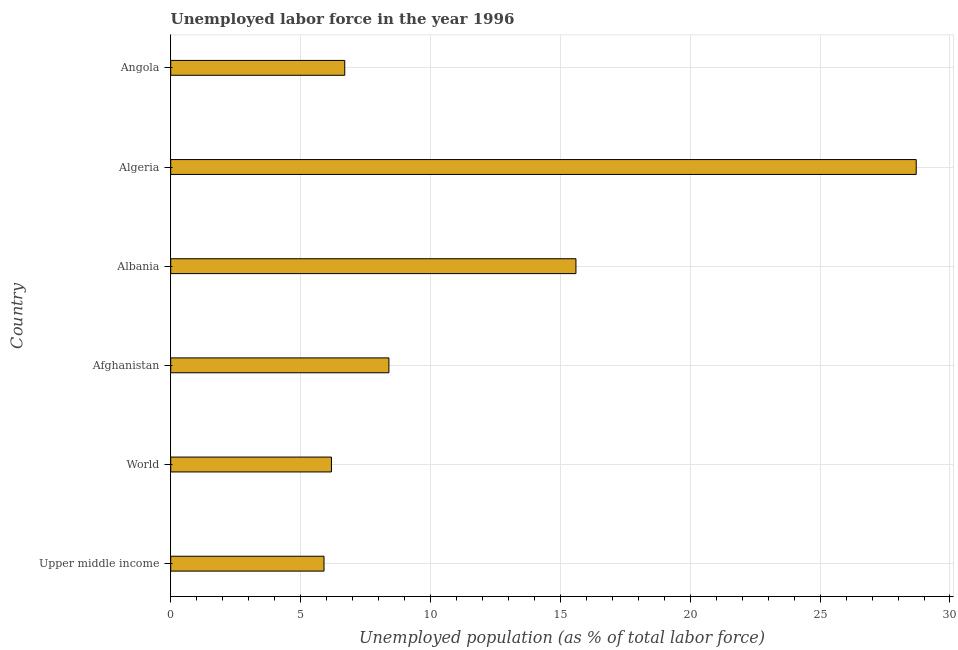Does the graph contain any zero values?
Ensure brevity in your answer.  No. Does the graph contain grids?
Give a very brief answer. Yes. What is the title of the graph?
Your answer should be very brief. Unemployed labor force in the year 1996. What is the label or title of the X-axis?
Provide a short and direct response. Unemployed population (as % of total labor force). What is the label or title of the Y-axis?
Offer a very short reply. Country. What is the total unemployed population in Algeria?
Provide a succinct answer. 28.7. Across all countries, what is the maximum total unemployed population?
Provide a succinct answer. 28.7. Across all countries, what is the minimum total unemployed population?
Your response must be concise. 5.9. In which country was the total unemployed population maximum?
Your answer should be compact. Algeria. In which country was the total unemployed population minimum?
Provide a succinct answer. Upper middle income. What is the sum of the total unemployed population?
Offer a terse response. 71.49. What is the difference between the total unemployed population in Afghanistan and Upper middle income?
Offer a very short reply. 2.5. What is the average total unemployed population per country?
Give a very brief answer. 11.91. What is the median total unemployed population?
Offer a very short reply. 7.55. What is the ratio of the total unemployed population in Albania to that in World?
Your response must be concise. 2.52. Is the difference between the total unemployed population in Albania and Angola greater than the difference between any two countries?
Your answer should be compact. No. What is the difference between the highest and the second highest total unemployed population?
Offer a terse response. 13.1. Is the sum of the total unemployed population in Albania and Upper middle income greater than the maximum total unemployed population across all countries?
Ensure brevity in your answer.  No. What is the difference between the highest and the lowest total unemployed population?
Offer a terse response. 22.8. How many bars are there?
Keep it short and to the point. 6. Are all the bars in the graph horizontal?
Provide a short and direct response. Yes. How many countries are there in the graph?
Make the answer very short. 6. What is the difference between two consecutive major ticks on the X-axis?
Give a very brief answer. 5. What is the Unemployed population (as % of total labor force) of Upper middle income?
Make the answer very short. 5.9. What is the Unemployed population (as % of total labor force) in World?
Your answer should be compact. 6.19. What is the Unemployed population (as % of total labor force) in Afghanistan?
Offer a terse response. 8.4. What is the Unemployed population (as % of total labor force) of Albania?
Provide a succinct answer. 15.6. What is the Unemployed population (as % of total labor force) of Algeria?
Ensure brevity in your answer.  28.7. What is the Unemployed population (as % of total labor force) of Angola?
Ensure brevity in your answer.  6.7. What is the difference between the Unemployed population (as % of total labor force) in Upper middle income and World?
Offer a terse response. -0.29. What is the difference between the Unemployed population (as % of total labor force) in Upper middle income and Afghanistan?
Offer a terse response. -2.5. What is the difference between the Unemployed population (as % of total labor force) in Upper middle income and Albania?
Ensure brevity in your answer.  -9.7. What is the difference between the Unemployed population (as % of total labor force) in Upper middle income and Algeria?
Your answer should be compact. -22.8. What is the difference between the Unemployed population (as % of total labor force) in Upper middle income and Angola?
Ensure brevity in your answer.  -0.8. What is the difference between the Unemployed population (as % of total labor force) in World and Afghanistan?
Your response must be concise. -2.21. What is the difference between the Unemployed population (as % of total labor force) in World and Albania?
Your response must be concise. -9.41. What is the difference between the Unemployed population (as % of total labor force) in World and Algeria?
Give a very brief answer. -22.51. What is the difference between the Unemployed population (as % of total labor force) in World and Angola?
Keep it short and to the point. -0.51. What is the difference between the Unemployed population (as % of total labor force) in Afghanistan and Algeria?
Your response must be concise. -20.3. What is the difference between the Unemployed population (as % of total labor force) in Afghanistan and Angola?
Make the answer very short. 1.7. What is the difference between the Unemployed population (as % of total labor force) in Albania and Algeria?
Your answer should be compact. -13.1. What is the difference between the Unemployed population (as % of total labor force) in Algeria and Angola?
Keep it short and to the point. 22. What is the ratio of the Unemployed population (as % of total labor force) in Upper middle income to that in World?
Your answer should be very brief. 0.95. What is the ratio of the Unemployed population (as % of total labor force) in Upper middle income to that in Afghanistan?
Offer a terse response. 0.7. What is the ratio of the Unemployed population (as % of total labor force) in Upper middle income to that in Albania?
Keep it short and to the point. 0.38. What is the ratio of the Unemployed population (as % of total labor force) in Upper middle income to that in Algeria?
Provide a succinct answer. 0.21. What is the ratio of the Unemployed population (as % of total labor force) in Upper middle income to that in Angola?
Provide a succinct answer. 0.88. What is the ratio of the Unemployed population (as % of total labor force) in World to that in Afghanistan?
Keep it short and to the point. 0.74. What is the ratio of the Unemployed population (as % of total labor force) in World to that in Albania?
Your answer should be compact. 0.4. What is the ratio of the Unemployed population (as % of total labor force) in World to that in Algeria?
Keep it short and to the point. 0.22. What is the ratio of the Unemployed population (as % of total labor force) in World to that in Angola?
Provide a short and direct response. 0.92. What is the ratio of the Unemployed population (as % of total labor force) in Afghanistan to that in Albania?
Offer a terse response. 0.54. What is the ratio of the Unemployed population (as % of total labor force) in Afghanistan to that in Algeria?
Provide a short and direct response. 0.29. What is the ratio of the Unemployed population (as % of total labor force) in Afghanistan to that in Angola?
Provide a short and direct response. 1.25. What is the ratio of the Unemployed population (as % of total labor force) in Albania to that in Algeria?
Ensure brevity in your answer.  0.54. What is the ratio of the Unemployed population (as % of total labor force) in Albania to that in Angola?
Provide a succinct answer. 2.33. What is the ratio of the Unemployed population (as % of total labor force) in Algeria to that in Angola?
Your answer should be compact. 4.28. 